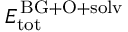Convert formula to latex. <formula><loc_0><loc_0><loc_500><loc_500>E _ { t o t } ^ { \, B G + O + s o l v }</formula> 